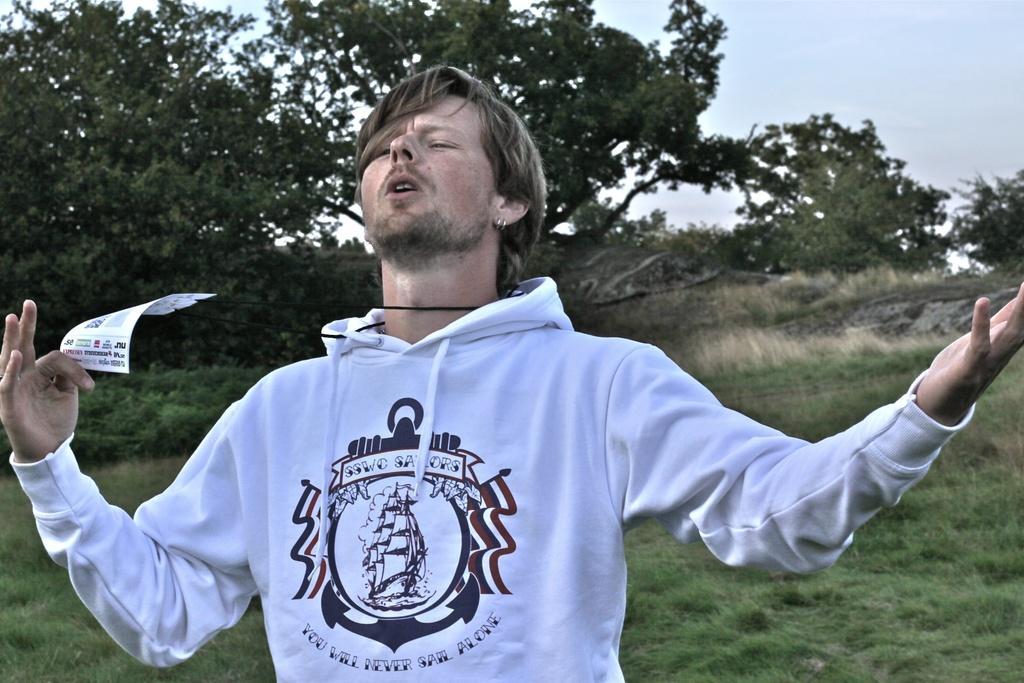What is the main subject of the image? There is a man in the image. What is the man wearing? The man is wearing a white hoodie. What is the man holding in his hand? The man is holding a paper in his hand. What can be seen in the background of the image? There is grass, trees, and the sky visible in the background of the image. What type of canvas is the man painting in the image? There is no canvas or painting activity present in the image. What topic is being discussed between the man and the trees in the background? There is no discussion or interaction between the man and the trees in the background; they are separate elements in the image. 